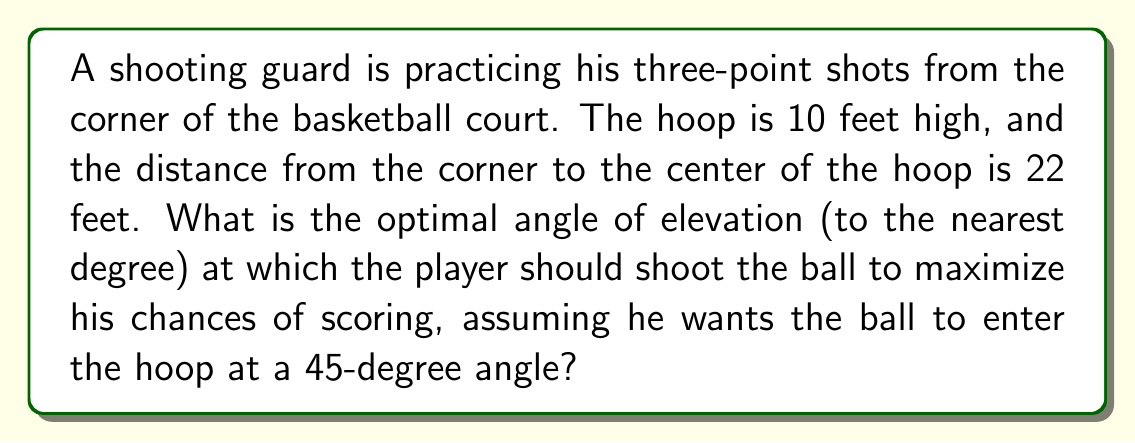Can you answer this question? Let's approach this step-by-step:

1) First, we need to visualize the problem. We have a right triangle where:
   - The base is the horizontal distance from the shooter to the hoop (22 feet)
   - The height is the difference between the hoop height and the release point
   - The hypotenuse is the path of the ball

2) Let's assume the player releases the ball at a height of 7 feet (a typical release height for a shooting guard).

3) The vertical distance the ball needs to travel is:
   $10 \text{ feet} - 7 \text{ feet} = 3 \text{ feet}$

4) Now we have a right triangle with:
   - Base = 22 feet
   - Height = 3 feet
   - Angle at the top (entry angle) = 45°

5) We need to find the angle at the bottom (release angle). Let's call this angle $\theta$.

6) In this triangle, $\tan(45°) = \frac{3}{x}$, where $x$ is the horizontal distance from the top of the arc to the hoop.

7) Solving for $x$: 
   $x = \frac{3}{\tan(45°)} = 3 \text{ feet}$

8) So, the ball needs to travel 19 feet horizontally before starting its 45° descent (22 - 3 = 19).

9) Now we have a new right triangle:
   - Base = 19 feet
   - Height = 3 feet
   - Hypotenuse = path of the ball
   - Angle we're looking for = $\theta$

10) We can find $\theta$ using the arctangent function:

    $$\theta = \arctan(\frac{3}{19})$$

11) Calculating this:
    $$\theta \approx 8.97°$$

12) Rounding to the nearest degree:
    $$\theta \approx 9°$$

Therefore, the optimal angle of elevation for the shot is approximately 9°.
Answer: 9° 